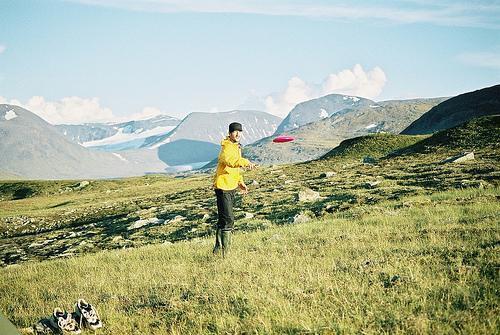How many frisbees are in the image?
Give a very brief answer. 1. 